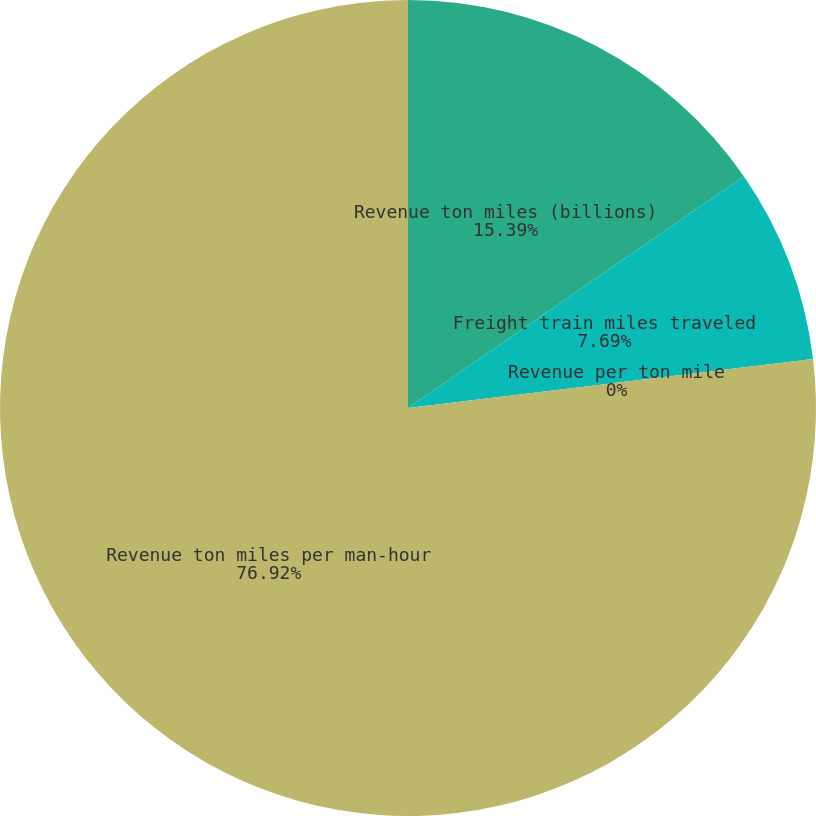Convert chart to OTSL. <chart><loc_0><loc_0><loc_500><loc_500><pie_chart><fcel>Revenue ton miles (billions)<fcel>Freight train miles traveled<fcel>Revenue per ton mile<fcel>Revenue ton miles per man-hour<nl><fcel>15.39%<fcel>7.69%<fcel>0.0%<fcel>76.92%<nl></chart> 